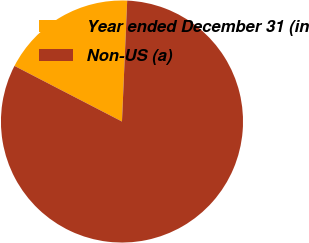Convert chart to OTSL. <chart><loc_0><loc_0><loc_500><loc_500><pie_chart><fcel>Year ended December 31 (in<fcel>Non-US (a)<nl><fcel>18.09%<fcel>81.91%<nl></chart> 